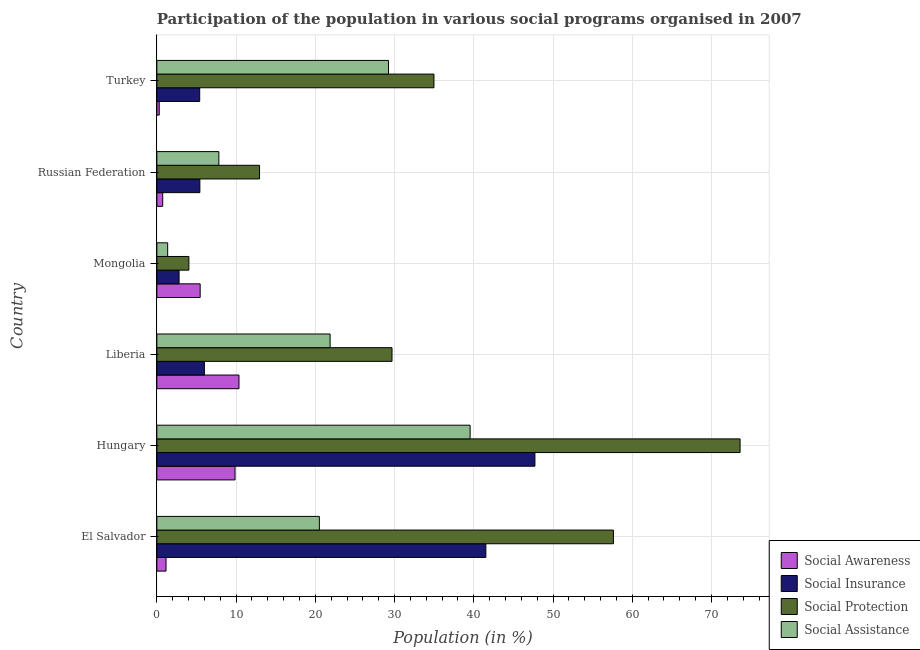How many groups of bars are there?
Your response must be concise. 6. How many bars are there on the 3rd tick from the top?
Provide a succinct answer. 4. How many bars are there on the 3rd tick from the bottom?
Your answer should be very brief. 4. What is the label of the 3rd group of bars from the top?
Your answer should be compact. Mongolia. What is the participation of population in social assistance programs in Mongolia?
Provide a short and direct response. 1.37. Across all countries, what is the maximum participation of population in social insurance programs?
Keep it short and to the point. 47.72. Across all countries, what is the minimum participation of population in social protection programs?
Offer a very short reply. 4.04. In which country was the participation of population in social assistance programs maximum?
Provide a short and direct response. Hungary. In which country was the participation of population in social assistance programs minimum?
Your answer should be very brief. Mongolia. What is the total participation of population in social awareness programs in the graph?
Your response must be concise. 27.9. What is the difference between the participation of population in social assistance programs in El Salvador and that in Russian Federation?
Your response must be concise. 12.68. What is the difference between the participation of population in social awareness programs in Hungary and the participation of population in social protection programs in El Salvador?
Make the answer very short. -47.75. What is the average participation of population in social awareness programs per country?
Offer a terse response. 4.65. What is the difference between the participation of population in social assistance programs and participation of population in social insurance programs in Mongolia?
Your response must be concise. -1.44. In how many countries, is the participation of population in social protection programs greater than 10 %?
Provide a succinct answer. 5. What is the ratio of the participation of population in social protection programs in Liberia to that in Russian Federation?
Your answer should be compact. 2.29. Is the participation of population in social insurance programs in Liberia less than that in Russian Federation?
Give a very brief answer. No. What is the difference between the highest and the second highest participation of population in social insurance programs?
Your answer should be compact. 6.19. What is the difference between the highest and the lowest participation of population in social assistance programs?
Ensure brevity in your answer.  38.17. Is it the case that in every country, the sum of the participation of population in social awareness programs and participation of population in social insurance programs is greater than the sum of participation of population in social assistance programs and participation of population in social protection programs?
Your answer should be very brief. No. What does the 2nd bar from the top in Russian Federation represents?
Provide a short and direct response. Social Protection. What does the 4th bar from the bottom in Russian Federation represents?
Provide a succinct answer. Social Assistance. How many bars are there?
Ensure brevity in your answer.  24. What is the difference between two consecutive major ticks on the X-axis?
Give a very brief answer. 10. Does the graph contain grids?
Keep it short and to the point. Yes. Where does the legend appear in the graph?
Offer a very short reply. Bottom right. What is the title of the graph?
Give a very brief answer. Participation of the population in various social programs organised in 2007. What is the label or title of the X-axis?
Your answer should be very brief. Population (in %). What is the label or title of the Y-axis?
Offer a very short reply. Country. What is the Population (in %) in Social Awareness in El Salvador?
Ensure brevity in your answer.  1.16. What is the Population (in %) in Social Insurance in El Salvador?
Your answer should be very brief. 41.52. What is the Population (in %) in Social Protection in El Salvador?
Ensure brevity in your answer.  57.62. What is the Population (in %) in Social Assistance in El Salvador?
Make the answer very short. 20.51. What is the Population (in %) in Social Awareness in Hungary?
Give a very brief answer. 9.87. What is the Population (in %) in Social Insurance in Hungary?
Make the answer very short. 47.72. What is the Population (in %) in Social Protection in Hungary?
Your answer should be compact. 73.61. What is the Population (in %) of Social Assistance in Hungary?
Ensure brevity in your answer.  39.53. What is the Population (in %) of Social Awareness in Liberia?
Provide a short and direct response. 10.37. What is the Population (in %) of Social Insurance in Liberia?
Your answer should be compact. 6. What is the Population (in %) in Social Protection in Liberia?
Offer a terse response. 29.68. What is the Population (in %) in Social Assistance in Liberia?
Offer a very short reply. 21.87. What is the Population (in %) of Social Awareness in Mongolia?
Give a very brief answer. 5.47. What is the Population (in %) of Social Insurance in Mongolia?
Make the answer very short. 2.8. What is the Population (in %) of Social Protection in Mongolia?
Provide a short and direct response. 4.04. What is the Population (in %) of Social Assistance in Mongolia?
Provide a succinct answer. 1.37. What is the Population (in %) of Social Awareness in Russian Federation?
Offer a terse response. 0.74. What is the Population (in %) of Social Insurance in Russian Federation?
Keep it short and to the point. 5.43. What is the Population (in %) of Social Protection in Russian Federation?
Offer a very short reply. 12.96. What is the Population (in %) of Social Assistance in Russian Federation?
Your answer should be very brief. 7.83. What is the Population (in %) of Social Awareness in Turkey?
Your answer should be compact. 0.3. What is the Population (in %) in Social Insurance in Turkey?
Offer a very short reply. 5.41. What is the Population (in %) in Social Protection in Turkey?
Ensure brevity in your answer.  34.97. What is the Population (in %) in Social Assistance in Turkey?
Make the answer very short. 29.24. Across all countries, what is the maximum Population (in %) of Social Awareness?
Give a very brief answer. 10.37. Across all countries, what is the maximum Population (in %) of Social Insurance?
Your answer should be compact. 47.72. Across all countries, what is the maximum Population (in %) in Social Protection?
Provide a short and direct response. 73.61. Across all countries, what is the maximum Population (in %) of Social Assistance?
Your answer should be compact. 39.53. Across all countries, what is the minimum Population (in %) of Social Awareness?
Provide a succinct answer. 0.3. Across all countries, what is the minimum Population (in %) in Social Insurance?
Ensure brevity in your answer.  2.8. Across all countries, what is the minimum Population (in %) in Social Protection?
Provide a succinct answer. 4.04. Across all countries, what is the minimum Population (in %) in Social Assistance?
Keep it short and to the point. 1.37. What is the total Population (in %) of Social Awareness in the graph?
Make the answer very short. 27.9. What is the total Population (in %) of Social Insurance in the graph?
Your answer should be compact. 108.88. What is the total Population (in %) of Social Protection in the graph?
Offer a terse response. 212.89. What is the total Population (in %) of Social Assistance in the graph?
Give a very brief answer. 120.34. What is the difference between the Population (in %) in Social Awareness in El Salvador and that in Hungary?
Offer a very short reply. -8.71. What is the difference between the Population (in %) of Social Insurance in El Salvador and that in Hungary?
Your answer should be very brief. -6.19. What is the difference between the Population (in %) in Social Protection in El Salvador and that in Hungary?
Give a very brief answer. -15.98. What is the difference between the Population (in %) in Social Assistance in El Salvador and that in Hungary?
Offer a very short reply. -19.03. What is the difference between the Population (in %) in Social Awareness in El Salvador and that in Liberia?
Give a very brief answer. -9.21. What is the difference between the Population (in %) in Social Insurance in El Salvador and that in Liberia?
Offer a terse response. 35.52. What is the difference between the Population (in %) in Social Protection in El Salvador and that in Liberia?
Your answer should be very brief. 27.94. What is the difference between the Population (in %) of Social Assistance in El Salvador and that in Liberia?
Offer a terse response. -1.36. What is the difference between the Population (in %) of Social Awareness in El Salvador and that in Mongolia?
Provide a short and direct response. -4.31. What is the difference between the Population (in %) of Social Insurance in El Salvador and that in Mongolia?
Provide a short and direct response. 38.72. What is the difference between the Population (in %) in Social Protection in El Salvador and that in Mongolia?
Your answer should be compact. 53.58. What is the difference between the Population (in %) of Social Assistance in El Salvador and that in Mongolia?
Your response must be concise. 19.14. What is the difference between the Population (in %) in Social Awareness in El Salvador and that in Russian Federation?
Provide a succinct answer. 0.42. What is the difference between the Population (in %) in Social Insurance in El Salvador and that in Russian Federation?
Your answer should be compact. 36.1. What is the difference between the Population (in %) in Social Protection in El Salvador and that in Russian Federation?
Offer a terse response. 44.66. What is the difference between the Population (in %) in Social Assistance in El Salvador and that in Russian Federation?
Your response must be concise. 12.68. What is the difference between the Population (in %) of Social Awareness in El Salvador and that in Turkey?
Ensure brevity in your answer.  0.86. What is the difference between the Population (in %) of Social Insurance in El Salvador and that in Turkey?
Your answer should be compact. 36.12. What is the difference between the Population (in %) of Social Protection in El Salvador and that in Turkey?
Provide a short and direct response. 22.65. What is the difference between the Population (in %) of Social Assistance in El Salvador and that in Turkey?
Your response must be concise. -8.73. What is the difference between the Population (in %) in Social Awareness in Hungary and that in Liberia?
Offer a very short reply. -0.5. What is the difference between the Population (in %) of Social Insurance in Hungary and that in Liberia?
Offer a terse response. 41.71. What is the difference between the Population (in %) of Social Protection in Hungary and that in Liberia?
Your answer should be compact. 43.93. What is the difference between the Population (in %) in Social Assistance in Hungary and that in Liberia?
Your response must be concise. 17.67. What is the difference between the Population (in %) of Social Awareness in Hungary and that in Mongolia?
Give a very brief answer. 4.4. What is the difference between the Population (in %) of Social Insurance in Hungary and that in Mongolia?
Give a very brief answer. 44.91. What is the difference between the Population (in %) of Social Protection in Hungary and that in Mongolia?
Provide a short and direct response. 69.57. What is the difference between the Population (in %) of Social Assistance in Hungary and that in Mongolia?
Your answer should be compact. 38.17. What is the difference between the Population (in %) in Social Awareness in Hungary and that in Russian Federation?
Provide a short and direct response. 9.13. What is the difference between the Population (in %) in Social Insurance in Hungary and that in Russian Federation?
Offer a very short reply. 42.29. What is the difference between the Population (in %) in Social Protection in Hungary and that in Russian Federation?
Offer a terse response. 60.65. What is the difference between the Population (in %) in Social Assistance in Hungary and that in Russian Federation?
Offer a terse response. 31.71. What is the difference between the Population (in %) of Social Awareness in Hungary and that in Turkey?
Provide a succinct answer. 9.57. What is the difference between the Population (in %) in Social Insurance in Hungary and that in Turkey?
Make the answer very short. 42.31. What is the difference between the Population (in %) of Social Protection in Hungary and that in Turkey?
Your answer should be compact. 38.64. What is the difference between the Population (in %) in Social Assistance in Hungary and that in Turkey?
Keep it short and to the point. 10.3. What is the difference between the Population (in %) of Social Awareness in Liberia and that in Mongolia?
Provide a short and direct response. 4.9. What is the difference between the Population (in %) in Social Insurance in Liberia and that in Mongolia?
Provide a short and direct response. 3.2. What is the difference between the Population (in %) of Social Protection in Liberia and that in Mongolia?
Your answer should be compact. 25.64. What is the difference between the Population (in %) of Social Assistance in Liberia and that in Mongolia?
Keep it short and to the point. 20.5. What is the difference between the Population (in %) in Social Awareness in Liberia and that in Russian Federation?
Offer a terse response. 9.63. What is the difference between the Population (in %) in Social Insurance in Liberia and that in Russian Federation?
Keep it short and to the point. 0.57. What is the difference between the Population (in %) of Social Protection in Liberia and that in Russian Federation?
Give a very brief answer. 16.72. What is the difference between the Population (in %) in Social Assistance in Liberia and that in Russian Federation?
Provide a short and direct response. 14.04. What is the difference between the Population (in %) in Social Awareness in Liberia and that in Turkey?
Keep it short and to the point. 10.06. What is the difference between the Population (in %) of Social Insurance in Liberia and that in Turkey?
Offer a terse response. 0.59. What is the difference between the Population (in %) in Social Protection in Liberia and that in Turkey?
Your response must be concise. -5.29. What is the difference between the Population (in %) in Social Assistance in Liberia and that in Turkey?
Give a very brief answer. -7.37. What is the difference between the Population (in %) in Social Awareness in Mongolia and that in Russian Federation?
Your answer should be very brief. 4.73. What is the difference between the Population (in %) in Social Insurance in Mongolia and that in Russian Federation?
Your answer should be very brief. -2.62. What is the difference between the Population (in %) of Social Protection in Mongolia and that in Russian Federation?
Ensure brevity in your answer.  -8.92. What is the difference between the Population (in %) of Social Assistance in Mongolia and that in Russian Federation?
Make the answer very short. -6.46. What is the difference between the Population (in %) in Social Awareness in Mongolia and that in Turkey?
Your response must be concise. 5.17. What is the difference between the Population (in %) in Social Insurance in Mongolia and that in Turkey?
Offer a terse response. -2.6. What is the difference between the Population (in %) in Social Protection in Mongolia and that in Turkey?
Offer a very short reply. -30.93. What is the difference between the Population (in %) of Social Assistance in Mongolia and that in Turkey?
Ensure brevity in your answer.  -27.87. What is the difference between the Population (in %) in Social Awareness in Russian Federation and that in Turkey?
Your answer should be compact. 0.44. What is the difference between the Population (in %) of Social Insurance in Russian Federation and that in Turkey?
Offer a very short reply. 0.02. What is the difference between the Population (in %) in Social Protection in Russian Federation and that in Turkey?
Your response must be concise. -22.01. What is the difference between the Population (in %) in Social Assistance in Russian Federation and that in Turkey?
Your response must be concise. -21.41. What is the difference between the Population (in %) of Social Awareness in El Salvador and the Population (in %) of Social Insurance in Hungary?
Keep it short and to the point. -46.56. What is the difference between the Population (in %) of Social Awareness in El Salvador and the Population (in %) of Social Protection in Hungary?
Provide a succinct answer. -72.45. What is the difference between the Population (in %) in Social Awareness in El Salvador and the Population (in %) in Social Assistance in Hungary?
Offer a terse response. -38.38. What is the difference between the Population (in %) of Social Insurance in El Salvador and the Population (in %) of Social Protection in Hungary?
Your response must be concise. -32.08. What is the difference between the Population (in %) in Social Insurance in El Salvador and the Population (in %) in Social Assistance in Hungary?
Your response must be concise. 1.99. What is the difference between the Population (in %) of Social Protection in El Salvador and the Population (in %) of Social Assistance in Hungary?
Your response must be concise. 18.09. What is the difference between the Population (in %) in Social Awareness in El Salvador and the Population (in %) in Social Insurance in Liberia?
Make the answer very short. -4.84. What is the difference between the Population (in %) in Social Awareness in El Salvador and the Population (in %) in Social Protection in Liberia?
Provide a succinct answer. -28.52. What is the difference between the Population (in %) in Social Awareness in El Salvador and the Population (in %) in Social Assistance in Liberia?
Give a very brief answer. -20.71. What is the difference between the Population (in %) of Social Insurance in El Salvador and the Population (in %) of Social Protection in Liberia?
Your response must be concise. 11.84. What is the difference between the Population (in %) of Social Insurance in El Salvador and the Population (in %) of Social Assistance in Liberia?
Provide a short and direct response. 19.66. What is the difference between the Population (in %) of Social Protection in El Salvador and the Population (in %) of Social Assistance in Liberia?
Keep it short and to the point. 35.76. What is the difference between the Population (in %) in Social Awareness in El Salvador and the Population (in %) in Social Insurance in Mongolia?
Your answer should be compact. -1.65. What is the difference between the Population (in %) of Social Awareness in El Salvador and the Population (in %) of Social Protection in Mongolia?
Offer a very short reply. -2.88. What is the difference between the Population (in %) of Social Awareness in El Salvador and the Population (in %) of Social Assistance in Mongolia?
Give a very brief answer. -0.21. What is the difference between the Population (in %) of Social Insurance in El Salvador and the Population (in %) of Social Protection in Mongolia?
Offer a very short reply. 37.48. What is the difference between the Population (in %) in Social Insurance in El Salvador and the Population (in %) in Social Assistance in Mongolia?
Provide a succinct answer. 40.16. What is the difference between the Population (in %) in Social Protection in El Salvador and the Population (in %) in Social Assistance in Mongolia?
Your answer should be very brief. 56.26. What is the difference between the Population (in %) in Social Awareness in El Salvador and the Population (in %) in Social Insurance in Russian Federation?
Your response must be concise. -4.27. What is the difference between the Population (in %) in Social Awareness in El Salvador and the Population (in %) in Social Protection in Russian Federation?
Make the answer very short. -11.8. What is the difference between the Population (in %) of Social Awareness in El Salvador and the Population (in %) of Social Assistance in Russian Federation?
Provide a short and direct response. -6.67. What is the difference between the Population (in %) in Social Insurance in El Salvador and the Population (in %) in Social Protection in Russian Federation?
Offer a terse response. 28.56. What is the difference between the Population (in %) of Social Insurance in El Salvador and the Population (in %) of Social Assistance in Russian Federation?
Provide a short and direct response. 33.7. What is the difference between the Population (in %) in Social Protection in El Salvador and the Population (in %) in Social Assistance in Russian Federation?
Keep it short and to the point. 49.8. What is the difference between the Population (in %) in Social Awareness in El Salvador and the Population (in %) in Social Insurance in Turkey?
Your response must be concise. -4.25. What is the difference between the Population (in %) in Social Awareness in El Salvador and the Population (in %) in Social Protection in Turkey?
Provide a short and direct response. -33.81. What is the difference between the Population (in %) in Social Awareness in El Salvador and the Population (in %) in Social Assistance in Turkey?
Make the answer very short. -28.08. What is the difference between the Population (in %) of Social Insurance in El Salvador and the Population (in %) of Social Protection in Turkey?
Your answer should be compact. 6.55. What is the difference between the Population (in %) in Social Insurance in El Salvador and the Population (in %) in Social Assistance in Turkey?
Ensure brevity in your answer.  12.29. What is the difference between the Population (in %) in Social Protection in El Salvador and the Population (in %) in Social Assistance in Turkey?
Your answer should be compact. 28.39. What is the difference between the Population (in %) in Social Awareness in Hungary and the Population (in %) in Social Insurance in Liberia?
Ensure brevity in your answer.  3.87. What is the difference between the Population (in %) of Social Awareness in Hungary and the Population (in %) of Social Protection in Liberia?
Provide a short and direct response. -19.81. What is the difference between the Population (in %) in Social Awareness in Hungary and the Population (in %) in Social Assistance in Liberia?
Your response must be concise. -12. What is the difference between the Population (in %) of Social Insurance in Hungary and the Population (in %) of Social Protection in Liberia?
Provide a succinct answer. 18.04. What is the difference between the Population (in %) of Social Insurance in Hungary and the Population (in %) of Social Assistance in Liberia?
Ensure brevity in your answer.  25.85. What is the difference between the Population (in %) of Social Protection in Hungary and the Population (in %) of Social Assistance in Liberia?
Give a very brief answer. 51.74. What is the difference between the Population (in %) in Social Awareness in Hungary and the Population (in %) in Social Insurance in Mongolia?
Provide a short and direct response. 7.06. What is the difference between the Population (in %) of Social Awareness in Hungary and the Population (in %) of Social Protection in Mongolia?
Provide a succinct answer. 5.83. What is the difference between the Population (in %) in Social Awareness in Hungary and the Population (in %) in Social Assistance in Mongolia?
Make the answer very short. 8.5. What is the difference between the Population (in %) of Social Insurance in Hungary and the Population (in %) of Social Protection in Mongolia?
Keep it short and to the point. 43.67. What is the difference between the Population (in %) of Social Insurance in Hungary and the Population (in %) of Social Assistance in Mongolia?
Offer a terse response. 46.35. What is the difference between the Population (in %) in Social Protection in Hungary and the Population (in %) in Social Assistance in Mongolia?
Provide a short and direct response. 72.24. What is the difference between the Population (in %) of Social Awareness in Hungary and the Population (in %) of Social Insurance in Russian Federation?
Your response must be concise. 4.44. What is the difference between the Population (in %) of Social Awareness in Hungary and the Population (in %) of Social Protection in Russian Federation?
Your answer should be very brief. -3.09. What is the difference between the Population (in %) of Social Awareness in Hungary and the Population (in %) of Social Assistance in Russian Federation?
Provide a short and direct response. 2.04. What is the difference between the Population (in %) in Social Insurance in Hungary and the Population (in %) in Social Protection in Russian Federation?
Your response must be concise. 34.75. What is the difference between the Population (in %) of Social Insurance in Hungary and the Population (in %) of Social Assistance in Russian Federation?
Your response must be concise. 39.89. What is the difference between the Population (in %) in Social Protection in Hungary and the Population (in %) in Social Assistance in Russian Federation?
Make the answer very short. 65.78. What is the difference between the Population (in %) in Social Awareness in Hungary and the Population (in %) in Social Insurance in Turkey?
Ensure brevity in your answer.  4.46. What is the difference between the Population (in %) of Social Awareness in Hungary and the Population (in %) of Social Protection in Turkey?
Your response must be concise. -25.1. What is the difference between the Population (in %) of Social Awareness in Hungary and the Population (in %) of Social Assistance in Turkey?
Keep it short and to the point. -19.37. What is the difference between the Population (in %) of Social Insurance in Hungary and the Population (in %) of Social Protection in Turkey?
Provide a succinct answer. 12.74. What is the difference between the Population (in %) in Social Insurance in Hungary and the Population (in %) in Social Assistance in Turkey?
Offer a terse response. 18.48. What is the difference between the Population (in %) in Social Protection in Hungary and the Population (in %) in Social Assistance in Turkey?
Ensure brevity in your answer.  44.37. What is the difference between the Population (in %) in Social Awareness in Liberia and the Population (in %) in Social Insurance in Mongolia?
Your response must be concise. 7.56. What is the difference between the Population (in %) in Social Awareness in Liberia and the Population (in %) in Social Protection in Mongolia?
Make the answer very short. 6.32. What is the difference between the Population (in %) of Social Awareness in Liberia and the Population (in %) of Social Assistance in Mongolia?
Your answer should be compact. 9. What is the difference between the Population (in %) of Social Insurance in Liberia and the Population (in %) of Social Protection in Mongolia?
Provide a short and direct response. 1.96. What is the difference between the Population (in %) of Social Insurance in Liberia and the Population (in %) of Social Assistance in Mongolia?
Your answer should be very brief. 4.64. What is the difference between the Population (in %) in Social Protection in Liberia and the Population (in %) in Social Assistance in Mongolia?
Offer a terse response. 28.31. What is the difference between the Population (in %) of Social Awareness in Liberia and the Population (in %) of Social Insurance in Russian Federation?
Your answer should be very brief. 4.94. What is the difference between the Population (in %) in Social Awareness in Liberia and the Population (in %) in Social Protection in Russian Federation?
Offer a very short reply. -2.6. What is the difference between the Population (in %) in Social Awareness in Liberia and the Population (in %) in Social Assistance in Russian Federation?
Your answer should be very brief. 2.54. What is the difference between the Population (in %) in Social Insurance in Liberia and the Population (in %) in Social Protection in Russian Federation?
Offer a very short reply. -6.96. What is the difference between the Population (in %) in Social Insurance in Liberia and the Population (in %) in Social Assistance in Russian Federation?
Provide a succinct answer. -1.82. What is the difference between the Population (in %) in Social Protection in Liberia and the Population (in %) in Social Assistance in Russian Federation?
Give a very brief answer. 21.85. What is the difference between the Population (in %) of Social Awareness in Liberia and the Population (in %) of Social Insurance in Turkey?
Your answer should be compact. 4.96. What is the difference between the Population (in %) of Social Awareness in Liberia and the Population (in %) of Social Protection in Turkey?
Provide a short and direct response. -24.61. What is the difference between the Population (in %) in Social Awareness in Liberia and the Population (in %) in Social Assistance in Turkey?
Offer a very short reply. -18.87. What is the difference between the Population (in %) in Social Insurance in Liberia and the Population (in %) in Social Protection in Turkey?
Give a very brief answer. -28.97. What is the difference between the Population (in %) of Social Insurance in Liberia and the Population (in %) of Social Assistance in Turkey?
Ensure brevity in your answer.  -23.24. What is the difference between the Population (in %) in Social Protection in Liberia and the Population (in %) in Social Assistance in Turkey?
Your answer should be very brief. 0.44. What is the difference between the Population (in %) in Social Awareness in Mongolia and the Population (in %) in Social Insurance in Russian Federation?
Give a very brief answer. 0.04. What is the difference between the Population (in %) in Social Awareness in Mongolia and the Population (in %) in Social Protection in Russian Federation?
Your response must be concise. -7.49. What is the difference between the Population (in %) of Social Awareness in Mongolia and the Population (in %) of Social Assistance in Russian Federation?
Provide a succinct answer. -2.36. What is the difference between the Population (in %) of Social Insurance in Mongolia and the Population (in %) of Social Protection in Russian Federation?
Ensure brevity in your answer.  -10.16. What is the difference between the Population (in %) of Social Insurance in Mongolia and the Population (in %) of Social Assistance in Russian Federation?
Give a very brief answer. -5.02. What is the difference between the Population (in %) in Social Protection in Mongolia and the Population (in %) in Social Assistance in Russian Federation?
Your answer should be compact. -3.78. What is the difference between the Population (in %) of Social Awareness in Mongolia and the Population (in %) of Social Insurance in Turkey?
Ensure brevity in your answer.  0.06. What is the difference between the Population (in %) of Social Awareness in Mongolia and the Population (in %) of Social Protection in Turkey?
Provide a succinct answer. -29.5. What is the difference between the Population (in %) of Social Awareness in Mongolia and the Population (in %) of Social Assistance in Turkey?
Provide a succinct answer. -23.77. What is the difference between the Population (in %) in Social Insurance in Mongolia and the Population (in %) in Social Protection in Turkey?
Your answer should be very brief. -32.17. What is the difference between the Population (in %) in Social Insurance in Mongolia and the Population (in %) in Social Assistance in Turkey?
Offer a terse response. -26.43. What is the difference between the Population (in %) in Social Protection in Mongolia and the Population (in %) in Social Assistance in Turkey?
Offer a terse response. -25.2. What is the difference between the Population (in %) in Social Awareness in Russian Federation and the Population (in %) in Social Insurance in Turkey?
Give a very brief answer. -4.67. What is the difference between the Population (in %) in Social Awareness in Russian Federation and the Population (in %) in Social Protection in Turkey?
Provide a succinct answer. -34.23. What is the difference between the Population (in %) of Social Awareness in Russian Federation and the Population (in %) of Social Assistance in Turkey?
Keep it short and to the point. -28.5. What is the difference between the Population (in %) in Social Insurance in Russian Federation and the Population (in %) in Social Protection in Turkey?
Make the answer very short. -29.54. What is the difference between the Population (in %) of Social Insurance in Russian Federation and the Population (in %) of Social Assistance in Turkey?
Ensure brevity in your answer.  -23.81. What is the difference between the Population (in %) in Social Protection in Russian Federation and the Population (in %) in Social Assistance in Turkey?
Give a very brief answer. -16.28. What is the average Population (in %) of Social Awareness per country?
Give a very brief answer. 4.65. What is the average Population (in %) in Social Insurance per country?
Keep it short and to the point. 18.15. What is the average Population (in %) in Social Protection per country?
Offer a very short reply. 35.48. What is the average Population (in %) in Social Assistance per country?
Give a very brief answer. 20.06. What is the difference between the Population (in %) of Social Awareness and Population (in %) of Social Insurance in El Salvador?
Provide a succinct answer. -40.36. What is the difference between the Population (in %) of Social Awareness and Population (in %) of Social Protection in El Salvador?
Offer a very short reply. -56.46. What is the difference between the Population (in %) in Social Awareness and Population (in %) in Social Assistance in El Salvador?
Give a very brief answer. -19.35. What is the difference between the Population (in %) in Social Insurance and Population (in %) in Social Protection in El Salvador?
Make the answer very short. -16.1. What is the difference between the Population (in %) in Social Insurance and Population (in %) in Social Assistance in El Salvador?
Keep it short and to the point. 21.01. What is the difference between the Population (in %) of Social Protection and Population (in %) of Social Assistance in El Salvador?
Ensure brevity in your answer.  37.11. What is the difference between the Population (in %) in Social Awareness and Population (in %) in Social Insurance in Hungary?
Offer a very short reply. -37.85. What is the difference between the Population (in %) in Social Awareness and Population (in %) in Social Protection in Hungary?
Provide a short and direct response. -63.74. What is the difference between the Population (in %) in Social Awareness and Population (in %) in Social Assistance in Hungary?
Your response must be concise. -29.67. What is the difference between the Population (in %) of Social Insurance and Population (in %) of Social Protection in Hungary?
Offer a terse response. -25.89. What is the difference between the Population (in %) of Social Insurance and Population (in %) of Social Assistance in Hungary?
Your answer should be compact. 8.18. What is the difference between the Population (in %) of Social Protection and Population (in %) of Social Assistance in Hungary?
Ensure brevity in your answer.  34.07. What is the difference between the Population (in %) of Social Awareness and Population (in %) of Social Insurance in Liberia?
Keep it short and to the point. 4.37. What is the difference between the Population (in %) of Social Awareness and Population (in %) of Social Protection in Liberia?
Ensure brevity in your answer.  -19.31. What is the difference between the Population (in %) in Social Awareness and Population (in %) in Social Assistance in Liberia?
Provide a short and direct response. -11.5. What is the difference between the Population (in %) in Social Insurance and Population (in %) in Social Protection in Liberia?
Your response must be concise. -23.68. What is the difference between the Population (in %) in Social Insurance and Population (in %) in Social Assistance in Liberia?
Give a very brief answer. -15.87. What is the difference between the Population (in %) of Social Protection and Population (in %) of Social Assistance in Liberia?
Your answer should be compact. 7.81. What is the difference between the Population (in %) of Social Awareness and Population (in %) of Social Insurance in Mongolia?
Offer a very short reply. 2.66. What is the difference between the Population (in %) in Social Awareness and Population (in %) in Social Protection in Mongolia?
Your answer should be compact. 1.43. What is the difference between the Population (in %) of Social Awareness and Population (in %) of Social Assistance in Mongolia?
Keep it short and to the point. 4.1. What is the difference between the Population (in %) of Social Insurance and Population (in %) of Social Protection in Mongolia?
Your answer should be very brief. -1.24. What is the difference between the Population (in %) in Social Insurance and Population (in %) in Social Assistance in Mongolia?
Provide a short and direct response. 1.44. What is the difference between the Population (in %) in Social Protection and Population (in %) in Social Assistance in Mongolia?
Offer a terse response. 2.68. What is the difference between the Population (in %) in Social Awareness and Population (in %) in Social Insurance in Russian Federation?
Give a very brief answer. -4.69. What is the difference between the Population (in %) in Social Awareness and Population (in %) in Social Protection in Russian Federation?
Give a very brief answer. -12.22. What is the difference between the Population (in %) in Social Awareness and Population (in %) in Social Assistance in Russian Federation?
Provide a short and direct response. -7.08. What is the difference between the Population (in %) of Social Insurance and Population (in %) of Social Protection in Russian Federation?
Provide a short and direct response. -7.53. What is the difference between the Population (in %) in Social Insurance and Population (in %) in Social Assistance in Russian Federation?
Provide a short and direct response. -2.4. What is the difference between the Population (in %) of Social Protection and Population (in %) of Social Assistance in Russian Federation?
Keep it short and to the point. 5.14. What is the difference between the Population (in %) of Social Awareness and Population (in %) of Social Insurance in Turkey?
Keep it short and to the point. -5.11. What is the difference between the Population (in %) in Social Awareness and Population (in %) in Social Protection in Turkey?
Your answer should be compact. -34.67. What is the difference between the Population (in %) of Social Awareness and Population (in %) of Social Assistance in Turkey?
Offer a very short reply. -28.94. What is the difference between the Population (in %) of Social Insurance and Population (in %) of Social Protection in Turkey?
Make the answer very short. -29.56. What is the difference between the Population (in %) of Social Insurance and Population (in %) of Social Assistance in Turkey?
Make the answer very short. -23.83. What is the difference between the Population (in %) of Social Protection and Population (in %) of Social Assistance in Turkey?
Keep it short and to the point. 5.74. What is the ratio of the Population (in %) in Social Awareness in El Salvador to that in Hungary?
Ensure brevity in your answer.  0.12. What is the ratio of the Population (in %) of Social Insurance in El Salvador to that in Hungary?
Give a very brief answer. 0.87. What is the ratio of the Population (in %) of Social Protection in El Salvador to that in Hungary?
Make the answer very short. 0.78. What is the ratio of the Population (in %) in Social Assistance in El Salvador to that in Hungary?
Your answer should be very brief. 0.52. What is the ratio of the Population (in %) of Social Awareness in El Salvador to that in Liberia?
Offer a terse response. 0.11. What is the ratio of the Population (in %) of Social Insurance in El Salvador to that in Liberia?
Give a very brief answer. 6.92. What is the ratio of the Population (in %) in Social Protection in El Salvador to that in Liberia?
Provide a succinct answer. 1.94. What is the ratio of the Population (in %) in Social Assistance in El Salvador to that in Liberia?
Provide a short and direct response. 0.94. What is the ratio of the Population (in %) of Social Awareness in El Salvador to that in Mongolia?
Your answer should be very brief. 0.21. What is the ratio of the Population (in %) of Social Insurance in El Salvador to that in Mongolia?
Give a very brief answer. 14.81. What is the ratio of the Population (in %) in Social Protection in El Salvador to that in Mongolia?
Ensure brevity in your answer.  14.26. What is the ratio of the Population (in %) in Social Assistance in El Salvador to that in Mongolia?
Offer a very short reply. 15.02. What is the ratio of the Population (in %) in Social Awareness in El Salvador to that in Russian Federation?
Give a very brief answer. 1.57. What is the ratio of the Population (in %) in Social Insurance in El Salvador to that in Russian Federation?
Your answer should be very brief. 7.65. What is the ratio of the Population (in %) of Social Protection in El Salvador to that in Russian Federation?
Provide a short and direct response. 4.45. What is the ratio of the Population (in %) in Social Assistance in El Salvador to that in Russian Federation?
Offer a terse response. 2.62. What is the ratio of the Population (in %) of Social Awareness in El Salvador to that in Turkey?
Provide a succinct answer. 3.85. What is the ratio of the Population (in %) of Social Insurance in El Salvador to that in Turkey?
Offer a very short reply. 7.68. What is the ratio of the Population (in %) of Social Protection in El Salvador to that in Turkey?
Provide a short and direct response. 1.65. What is the ratio of the Population (in %) in Social Assistance in El Salvador to that in Turkey?
Provide a succinct answer. 0.7. What is the ratio of the Population (in %) in Social Awareness in Hungary to that in Liberia?
Your answer should be compact. 0.95. What is the ratio of the Population (in %) of Social Insurance in Hungary to that in Liberia?
Keep it short and to the point. 7.95. What is the ratio of the Population (in %) in Social Protection in Hungary to that in Liberia?
Your response must be concise. 2.48. What is the ratio of the Population (in %) in Social Assistance in Hungary to that in Liberia?
Offer a very short reply. 1.81. What is the ratio of the Population (in %) in Social Awareness in Hungary to that in Mongolia?
Offer a very short reply. 1.8. What is the ratio of the Population (in %) of Social Insurance in Hungary to that in Mongolia?
Keep it short and to the point. 17.01. What is the ratio of the Population (in %) of Social Protection in Hungary to that in Mongolia?
Give a very brief answer. 18.21. What is the ratio of the Population (in %) of Social Assistance in Hungary to that in Mongolia?
Make the answer very short. 28.96. What is the ratio of the Population (in %) of Social Awareness in Hungary to that in Russian Federation?
Ensure brevity in your answer.  13.33. What is the ratio of the Population (in %) in Social Insurance in Hungary to that in Russian Federation?
Give a very brief answer. 8.79. What is the ratio of the Population (in %) in Social Protection in Hungary to that in Russian Federation?
Provide a succinct answer. 5.68. What is the ratio of the Population (in %) in Social Assistance in Hungary to that in Russian Federation?
Ensure brevity in your answer.  5.05. What is the ratio of the Population (in %) of Social Awareness in Hungary to that in Turkey?
Your response must be concise. 32.8. What is the ratio of the Population (in %) of Social Insurance in Hungary to that in Turkey?
Give a very brief answer. 8.82. What is the ratio of the Population (in %) of Social Protection in Hungary to that in Turkey?
Keep it short and to the point. 2.1. What is the ratio of the Population (in %) of Social Assistance in Hungary to that in Turkey?
Provide a short and direct response. 1.35. What is the ratio of the Population (in %) in Social Awareness in Liberia to that in Mongolia?
Make the answer very short. 1.9. What is the ratio of the Population (in %) of Social Insurance in Liberia to that in Mongolia?
Your answer should be compact. 2.14. What is the ratio of the Population (in %) of Social Protection in Liberia to that in Mongolia?
Offer a terse response. 7.34. What is the ratio of the Population (in %) in Social Assistance in Liberia to that in Mongolia?
Ensure brevity in your answer.  16.02. What is the ratio of the Population (in %) in Social Awareness in Liberia to that in Russian Federation?
Give a very brief answer. 14. What is the ratio of the Population (in %) of Social Insurance in Liberia to that in Russian Federation?
Your answer should be very brief. 1.11. What is the ratio of the Population (in %) of Social Protection in Liberia to that in Russian Federation?
Your response must be concise. 2.29. What is the ratio of the Population (in %) in Social Assistance in Liberia to that in Russian Federation?
Give a very brief answer. 2.79. What is the ratio of the Population (in %) in Social Awareness in Liberia to that in Turkey?
Provide a short and direct response. 34.45. What is the ratio of the Population (in %) in Social Insurance in Liberia to that in Turkey?
Offer a very short reply. 1.11. What is the ratio of the Population (in %) of Social Protection in Liberia to that in Turkey?
Ensure brevity in your answer.  0.85. What is the ratio of the Population (in %) of Social Assistance in Liberia to that in Turkey?
Your answer should be very brief. 0.75. What is the ratio of the Population (in %) of Social Awareness in Mongolia to that in Russian Federation?
Ensure brevity in your answer.  7.39. What is the ratio of the Population (in %) in Social Insurance in Mongolia to that in Russian Federation?
Offer a terse response. 0.52. What is the ratio of the Population (in %) in Social Protection in Mongolia to that in Russian Federation?
Give a very brief answer. 0.31. What is the ratio of the Population (in %) in Social Assistance in Mongolia to that in Russian Federation?
Your answer should be compact. 0.17. What is the ratio of the Population (in %) in Social Awareness in Mongolia to that in Turkey?
Your answer should be compact. 18.17. What is the ratio of the Population (in %) of Social Insurance in Mongolia to that in Turkey?
Your answer should be compact. 0.52. What is the ratio of the Population (in %) in Social Protection in Mongolia to that in Turkey?
Keep it short and to the point. 0.12. What is the ratio of the Population (in %) of Social Assistance in Mongolia to that in Turkey?
Offer a very short reply. 0.05. What is the ratio of the Population (in %) in Social Awareness in Russian Federation to that in Turkey?
Your answer should be compact. 2.46. What is the ratio of the Population (in %) in Social Insurance in Russian Federation to that in Turkey?
Offer a terse response. 1. What is the ratio of the Population (in %) in Social Protection in Russian Federation to that in Turkey?
Give a very brief answer. 0.37. What is the ratio of the Population (in %) in Social Assistance in Russian Federation to that in Turkey?
Make the answer very short. 0.27. What is the difference between the highest and the second highest Population (in %) of Social Awareness?
Provide a short and direct response. 0.5. What is the difference between the highest and the second highest Population (in %) in Social Insurance?
Give a very brief answer. 6.19. What is the difference between the highest and the second highest Population (in %) of Social Protection?
Offer a terse response. 15.98. What is the difference between the highest and the second highest Population (in %) of Social Assistance?
Give a very brief answer. 10.3. What is the difference between the highest and the lowest Population (in %) in Social Awareness?
Keep it short and to the point. 10.06. What is the difference between the highest and the lowest Population (in %) of Social Insurance?
Your answer should be compact. 44.91. What is the difference between the highest and the lowest Population (in %) in Social Protection?
Provide a succinct answer. 69.57. What is the difference between the highest and the lowest Population (in %) of Social Assistance?
Offer a very short reply. 38.17. 